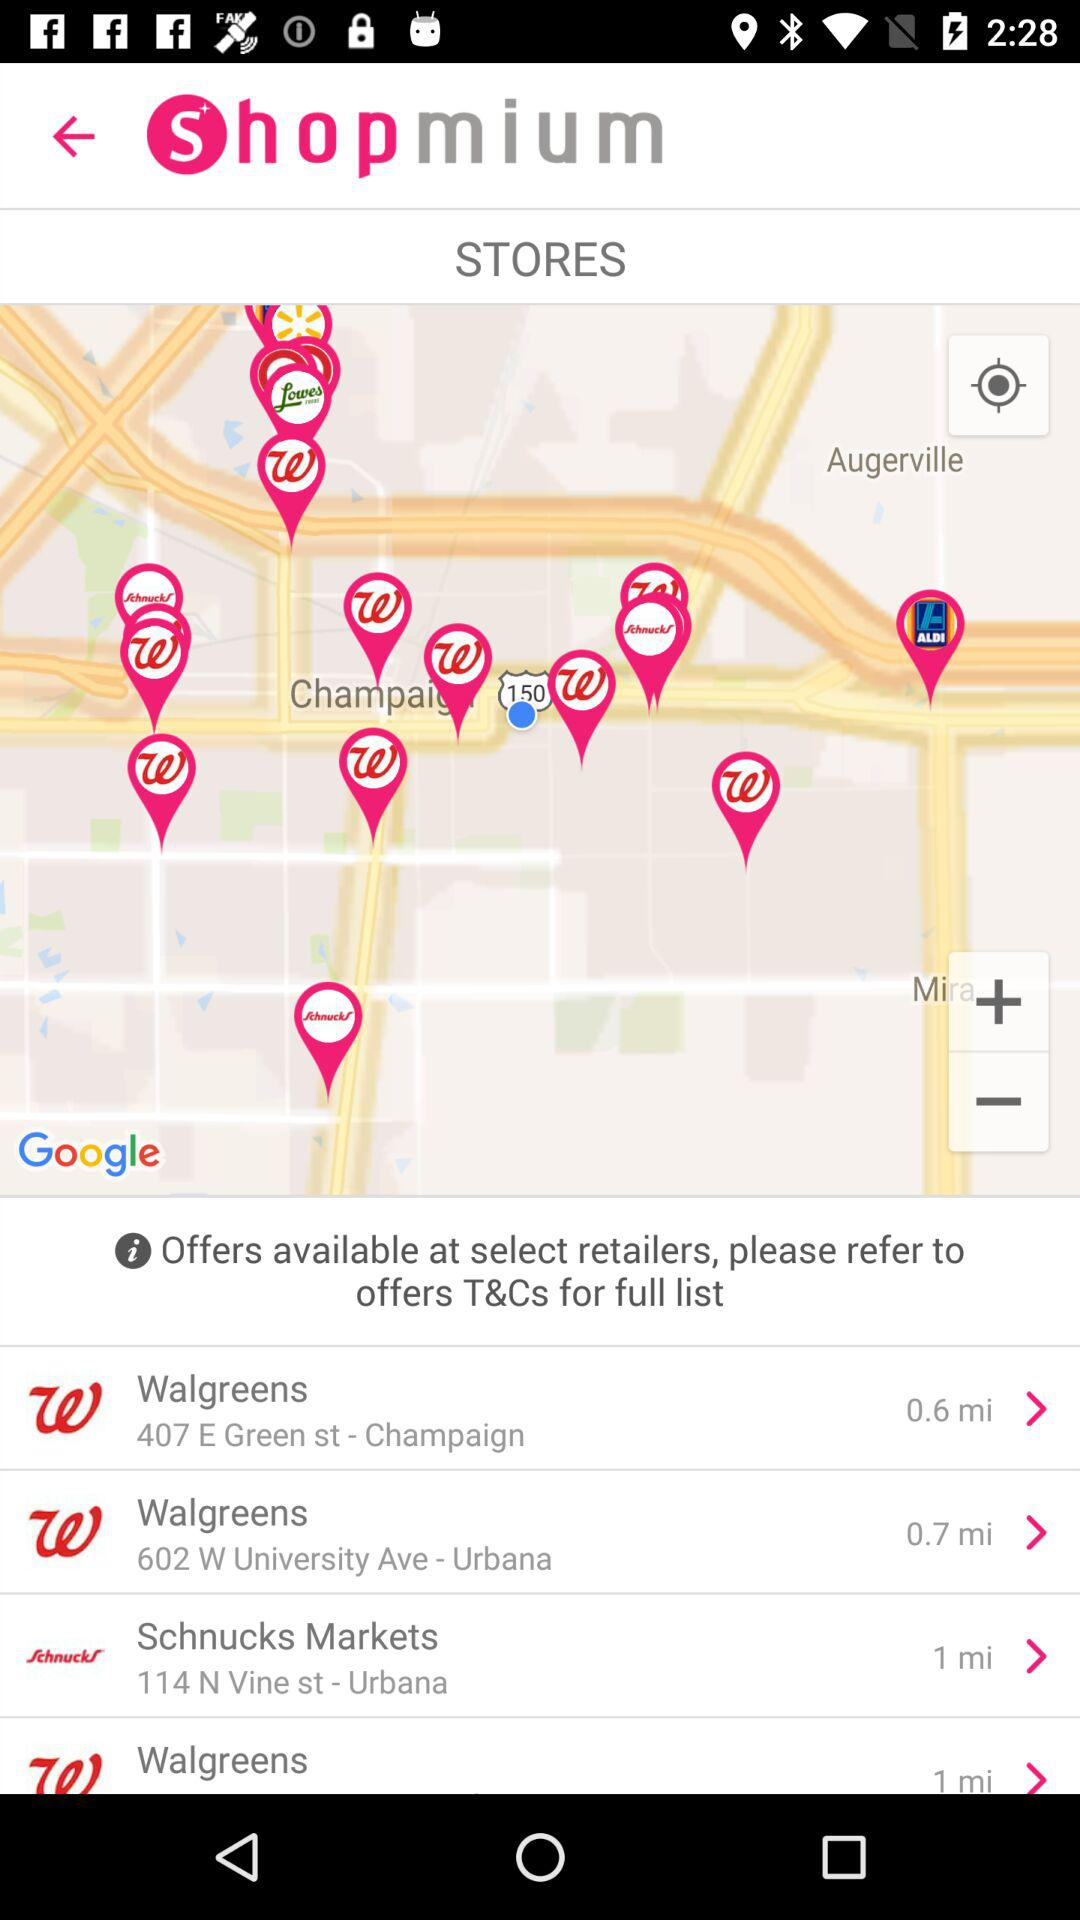What is the name of the application? The name of the application is "Shopmium". 